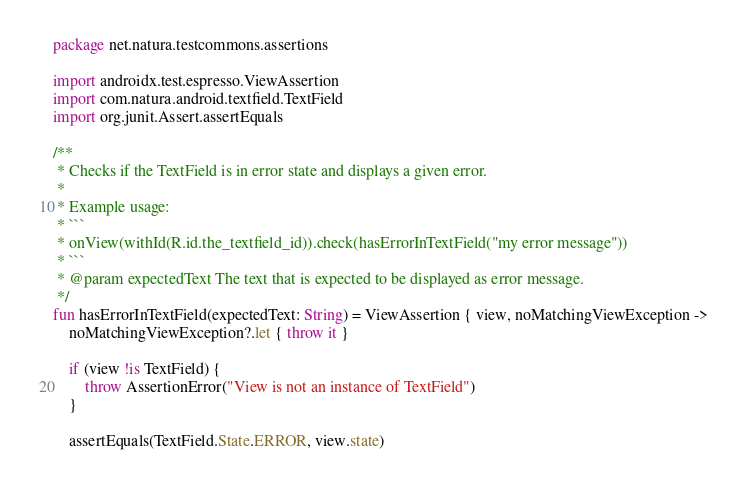Convert code to text. <code><loc_0><loc_0><loc_500><loc_500><_Kotlin_>package net.natura.testcommons.assertions

import androidx.test.espresso.ViewAssertion
import com.natura.android.textfield.TextField
import org.junit.Assert.assertEquals

/**
 * Checks if the TextField is in error state and displays a given error.
 *
 * Example usage:
 * ```
 * onView(withId(R.id.the_textfield_id)).check(hasErrorInTextField("my error message"))
 * ```
 * @param expectedText The text that is expected to be displayed as error message.
 */
fun hasErrorInTextField(expectedText: String) = ViewAssertion { view, noMatchingViewException ->
    noMatchingViewException?.let { throw it }

    if (view !is TextField) {
        throw AssertionError("View is not an instance of TextField")
    }

    assertEquals(TextField.State.ERROR, view.state)</code> 